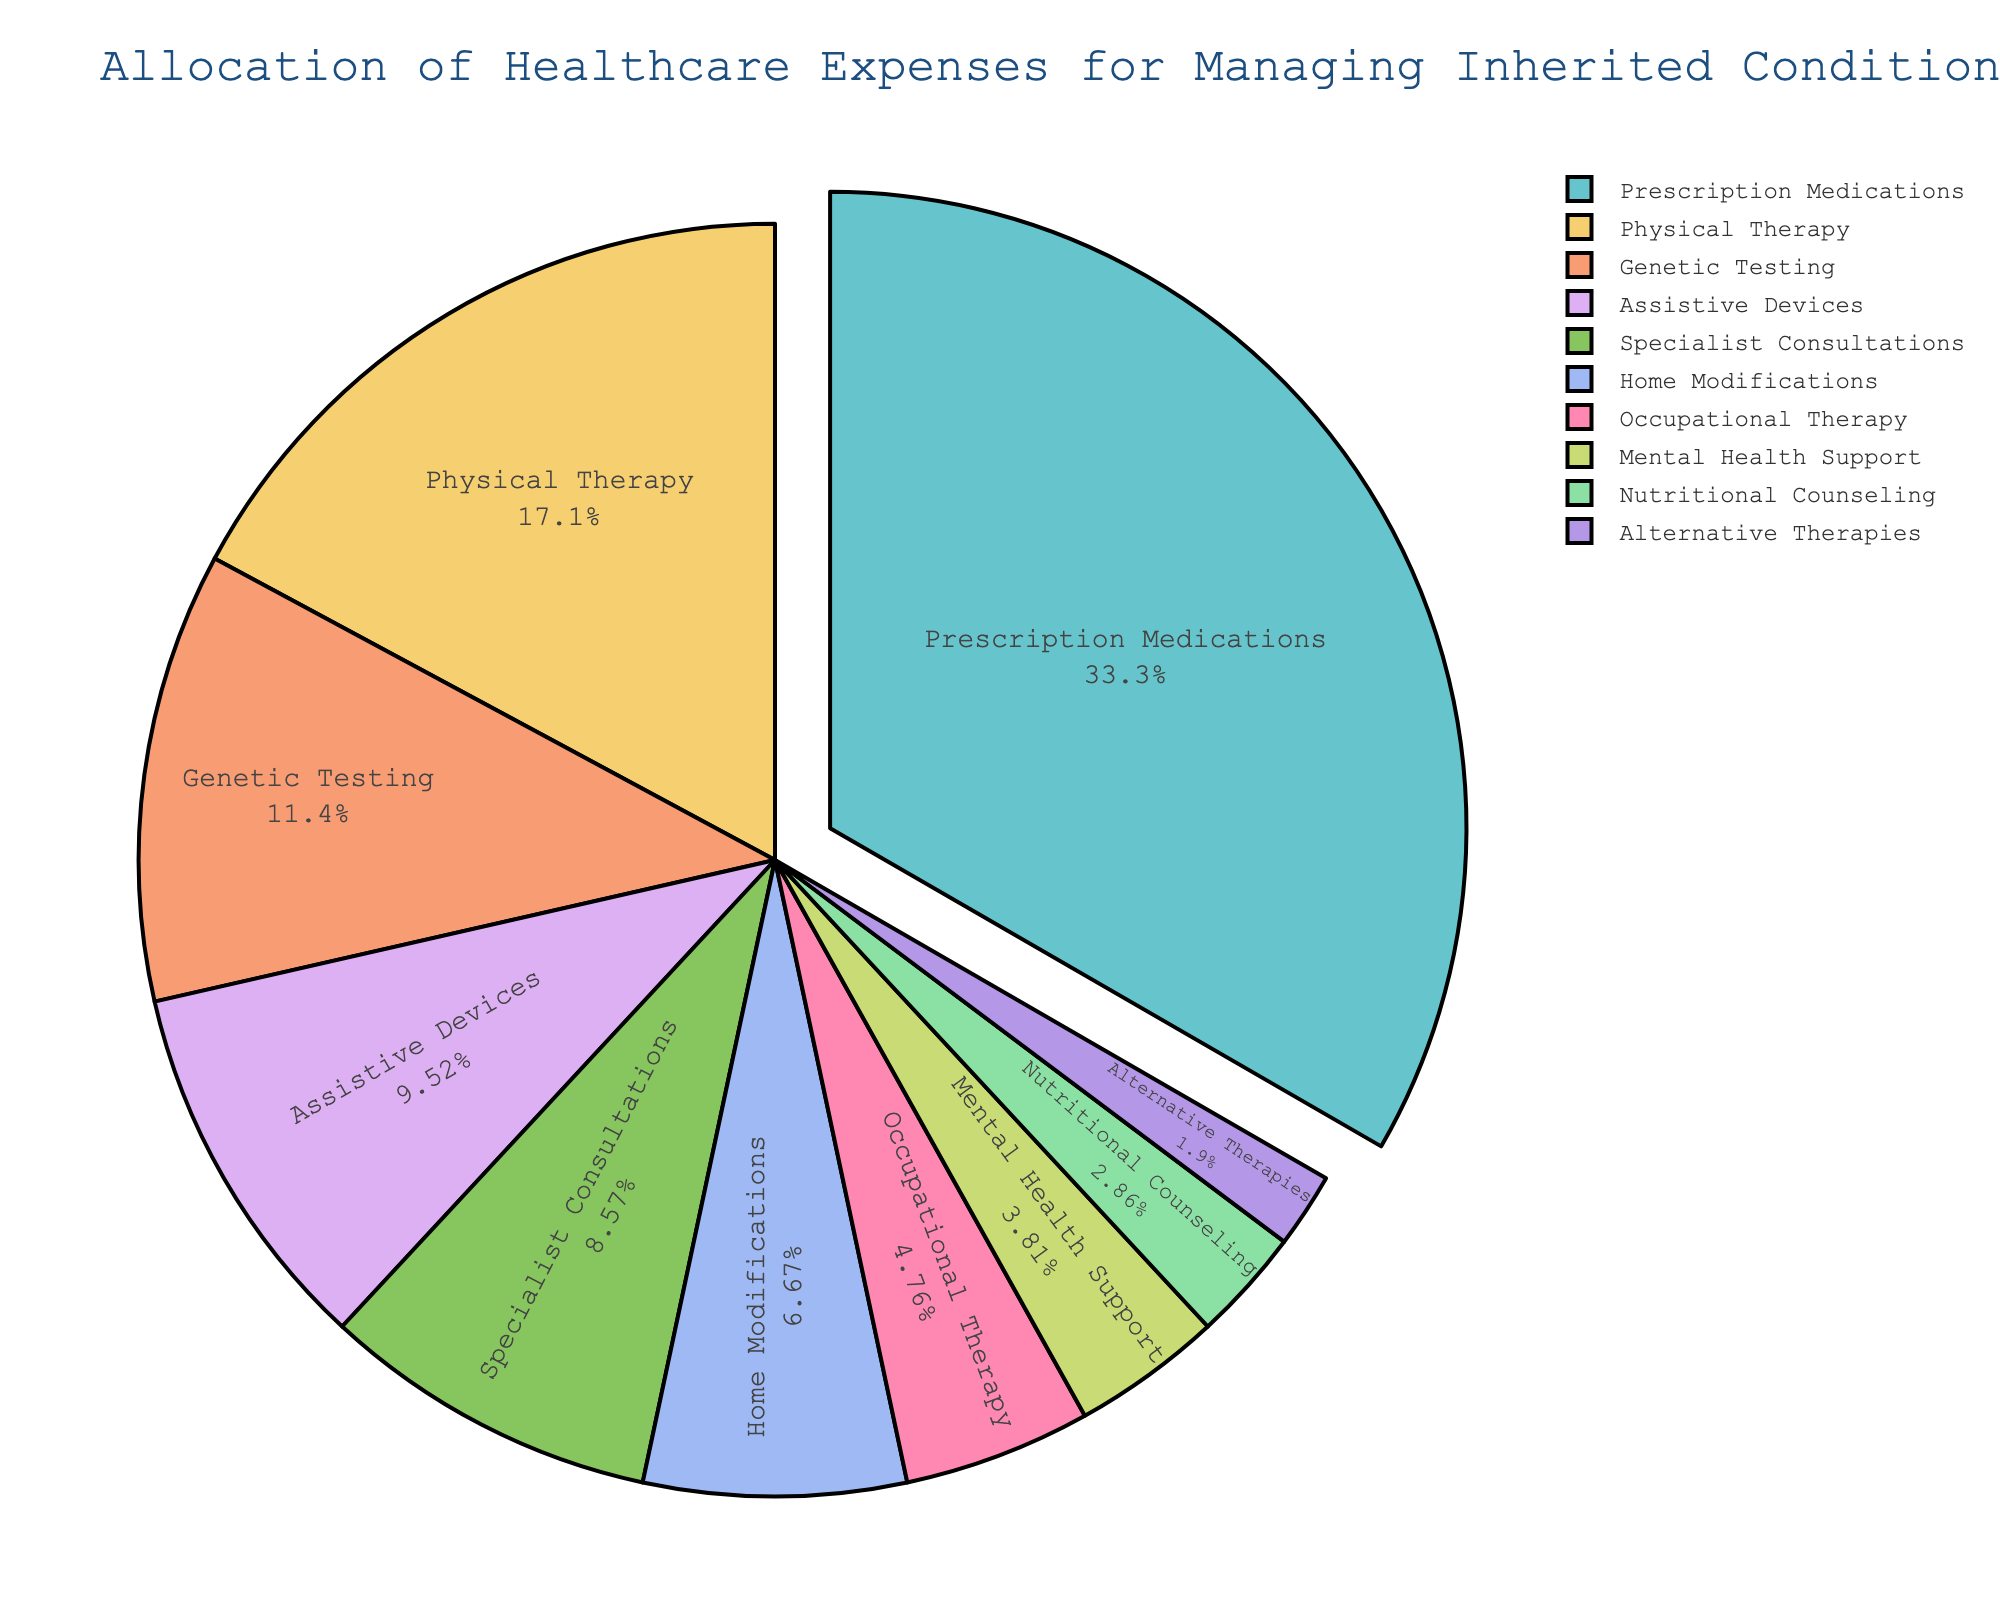What percentage of the total expenses is allocated to Prescription Medications? The pie chart indicates that Prescription Medications account for 35% of the total healthcare expenses allocated for managing inherited conditions.
Answer: 35% Which category has the smallest allocation, and what is its percentage? The pie chart shows that Alternative Therapies have the smallest allocation, with a percentage of 2%.
Answer: Alternative Therapies, 2% How much more is spent on Prescription Medications compared to Genetic Testing? The pie chart shows that Prescription Medications have a 35% allocation, while Genetic Testing has a 12% allocation. The difference is 35% - 12% = 23%.
Answer: 23% What is the combined percentage for Physical Therapy and Occupational Therapy? From the pie chart, Physical Therapy is 18% and Occupational Therapy is 5%. The combined percentage is 18% + 5% = 23%.
Answer: 23% Which category, that constitutes less than 10% of the expenses, has the highest allocation? The categories constituting less than 10% are Specialist Consultations, Home Modifications, Occupational Therapy, Mental Health Support, Nutritional Counseling, and Alternative Therapies. Among these, Specialist Consultations have the highest allocation with 9%.
Answer: Specialist Consultations, 9% What fraction of the total expenses is assigned to categories that involve therapy (Physical Therapy, Occupational Therapy, Mental Health Support)? The pie chart shows that Physical Therapy is 18%, Occupational Therapy is 5%, and Mental Health Support is 4%. The total allocation for these therapies is 18% + 5% + 4% = 27%.
Answer: 27% How does the allocation for Home Modifications compare to that for Assistive Devices in percentage terms? The pie chart shows Home Modifications are allocated 7%, while Assistive Devices have an allocation of 10%. Therefore, Home Modifications have 3% less allocation compared to Assistive Devices.
Answer: 3% less What is the total percentage allocation of the three least-funded categories? The three least-funded categories are Occupational Therapy (5%), Mental Health Support (4%), and Nutritional Counseling (3%). Their total allocation is 5% + 4% + 3% = 12%.
Answer: 12% Which category is represented by the largest portion of the pie chart, and what percentage does it cover? The pie chart indicates that Prescription Medications cover the largest portion, with a percentage of 35%.
Answer: Prescription Medications, 35% How does the total percentage of Specialist Consultations and Home Modifications compare to the percentage for Genetic Testing? The pie chart shows Specialist Consultations at 9% and Home Modifications at 7%, giving a total of 9% + 7% = 16%. Genetic Testing alone has a 12% allocation, so the total for Specialist Consultations and Home Modifications is 4% higher than Genetic Testing.
Answer: 4% higher 